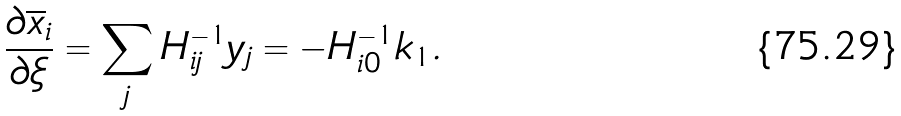<formula> <loc_0><loc_0><loc_500><loc_500>\frac { \partial \overline { x } _ { i } } { \partial \xi } = \sum _ { j } H ^ { - 1 } _ { i j } y _ { j } = - H ^ { - 1 } _ { i 0 } k _ { 1 } .</formula> 